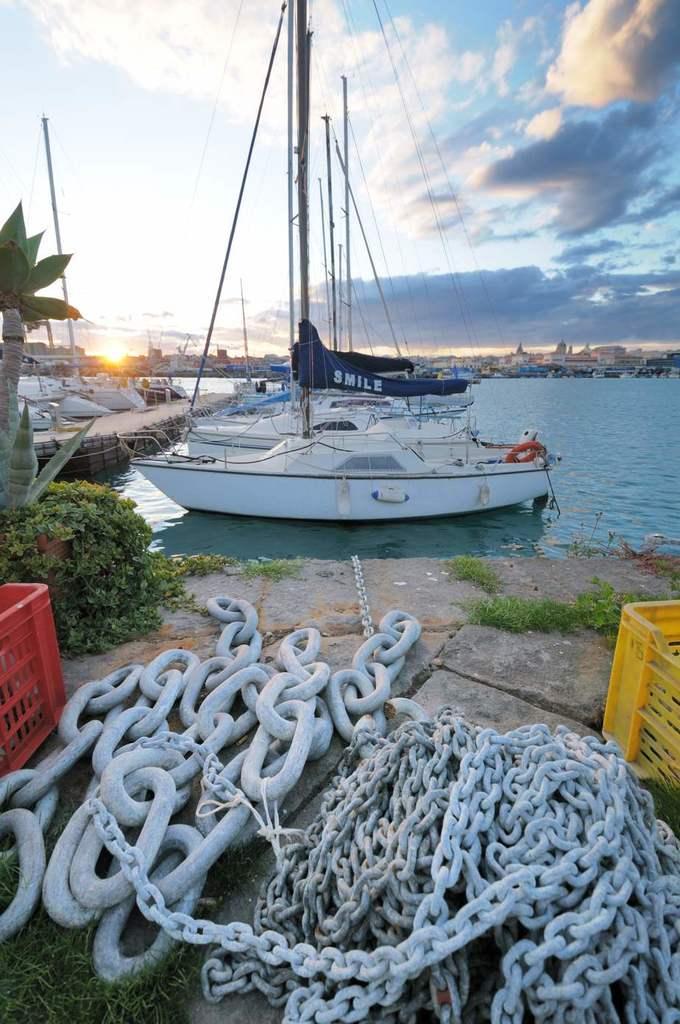In one or two sentences, can you explain what this image depicts? In this image we can see a few boats on the river. On the left side there are a few plants and trees. At the bottom of the image there are few chains and baskets. In the background there are buildings and a sky. 